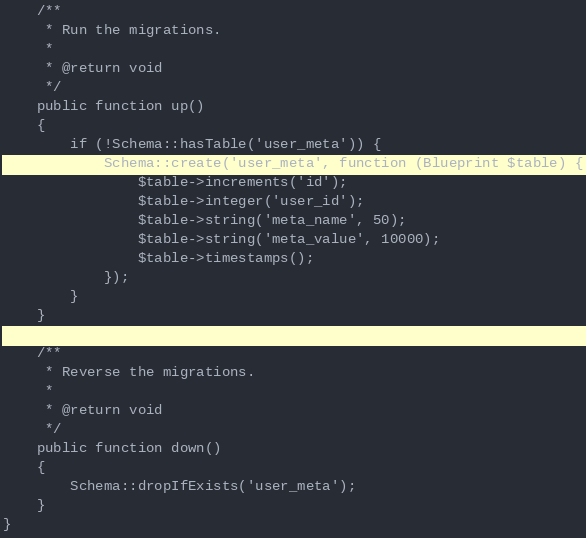<code> <loc_0><loc_0><loc_500><loc_500><_PHP_>    /**
     * Run the migrations.
     *
     * @return void
     */
    public function up()
    {
        if (!Schema::hasTable('user_meta')) {
            Schema::create('user_meta', function (Blueprint $table) {
                $table->increments('id');
                $table->integer('user_id');
                $table->string('meta_name', 50);
                $table->string('meta_value', 10000);
                $table->timestamps();
            });
        }
    }

    /**
     * Reverse the migrations.
     *
     * @return void
     */
    public function down()
    {
        Schema::dropIfExists('user_meta');
    }
}
</code> 